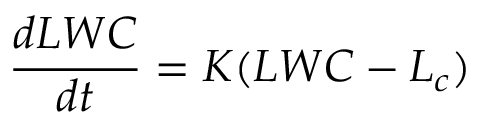Convert formula to latex. <formula><loc_0><loc_0><loc_500><loc_500>\frac { d L W C } { d t } = K ( L W C - L _ { c } )</formula> 